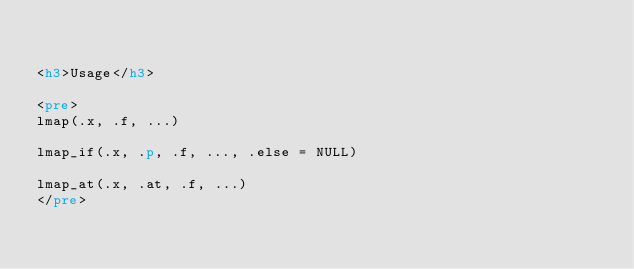<code> <loc_0><loc_0><loc_500><loc_500><_HTML_>

<h3>Usage</h3>

<pre>
lmap(.x, .f, ...)

lmap_if(.x, .p, .f, ..., .else = NULL)

lmap_at(.x, .at, .f, ...)
</pre>

</code> 